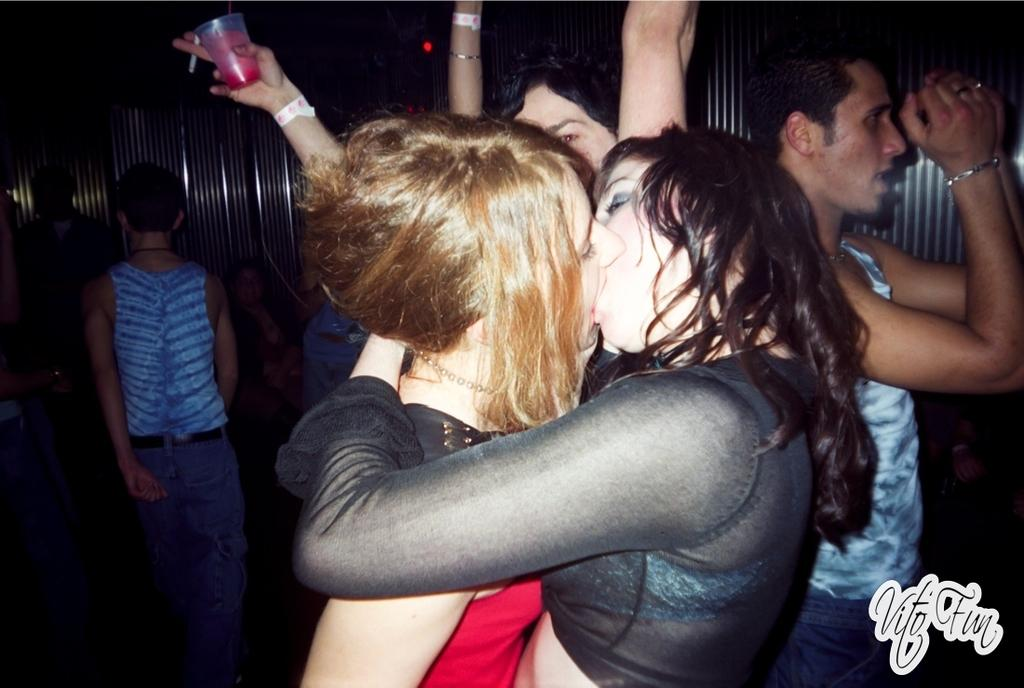What are the two persons in the image doing? The two persons in the image are kissing. What can be observed about the attire of the persons in the image? Both persons are wearing clothes. Can you describe the presence of other people in the image? There is another person on the left side of the image and another person on the right side of the image. What type of fuel is being used by the person on the left side of the image? There is no indication of any fuel or vehicle in the image, so it cannot be determined what type of fuel might be used. 